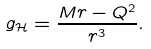<formula> <loc_0><loc_0><loc_500><loc_500>g _ { \mathcal { H } } = \frac { M r - Q ^ { 2 } } { r ^ { 3 } } .</formula> 